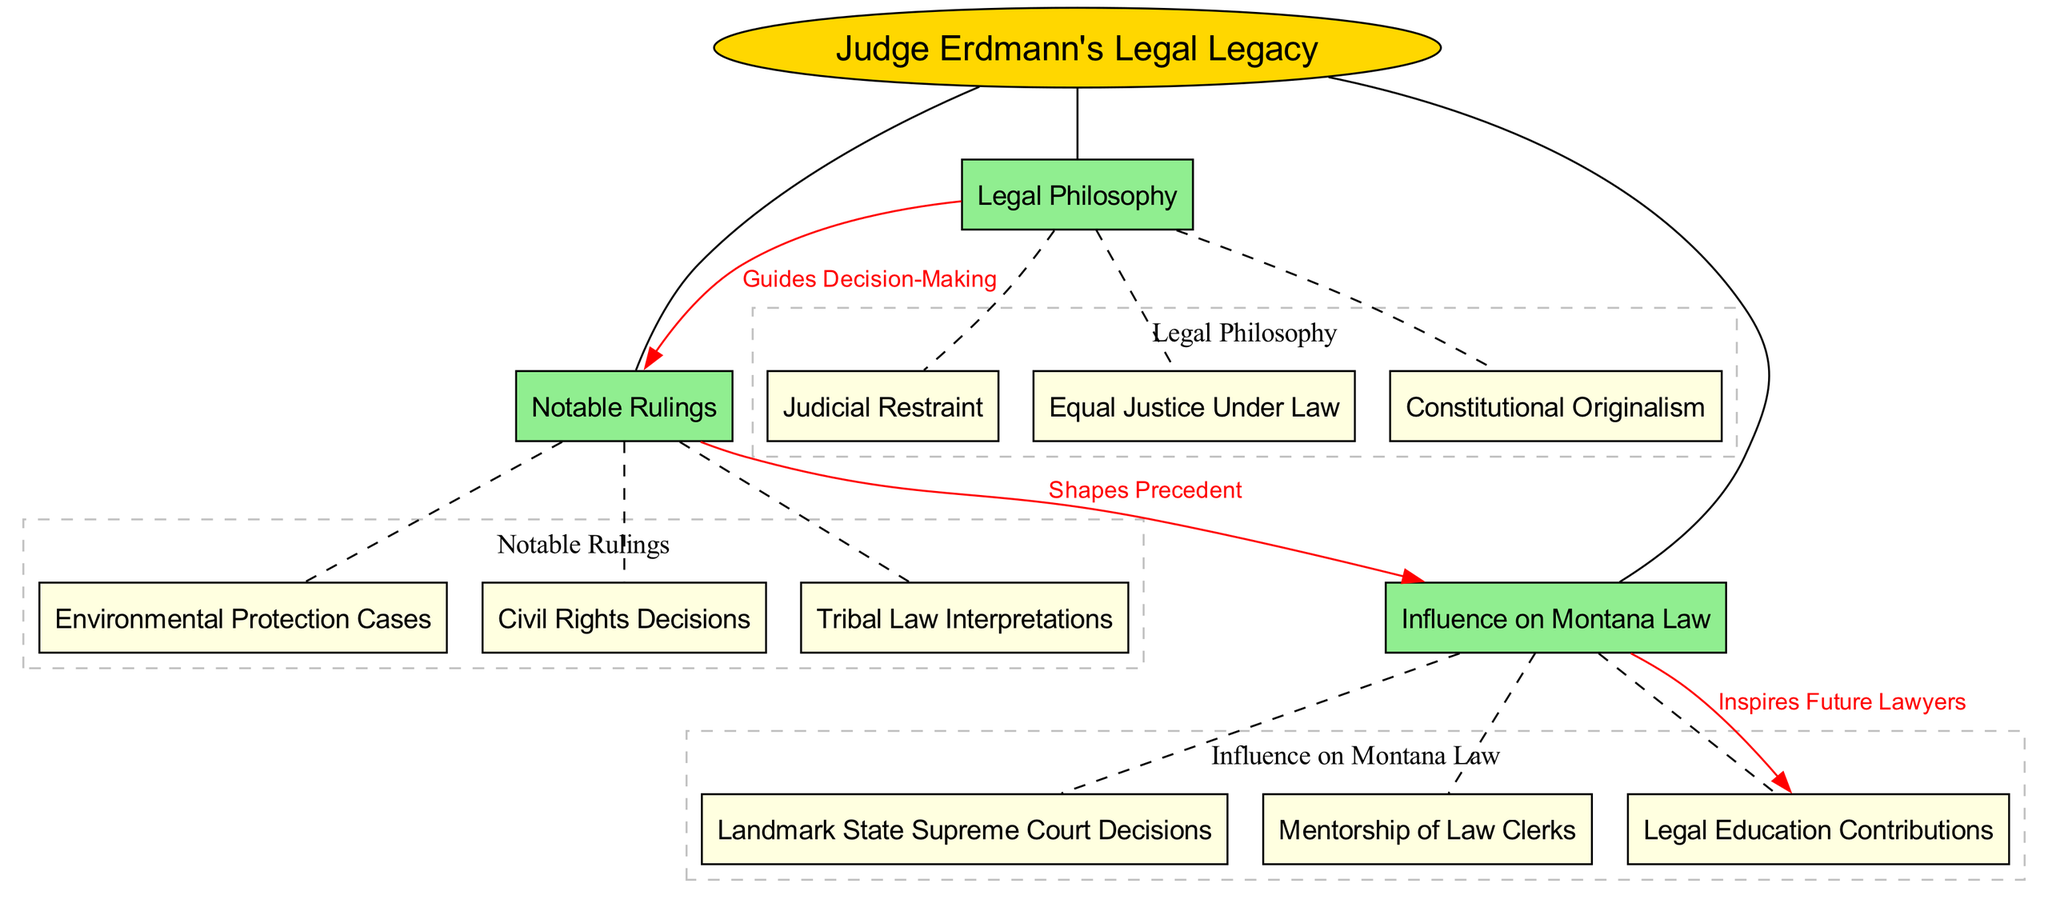What is the central concept of the diagram? The central concept is labeled as "Judge Erdmann's Legal Legacy," which serves as the main topic of the concept map and connects all other nodes.
Answer: Judge Erdmann's Legal Legacy How many main nodes are present in the diagram? The diagram includes three main nodes: "Notable Rulings," "Legal Philosophy," and "Influence on Montana Law." Counting them gives a total of three.
Answer: 3 Which legal philosophy is associated with guiding decision-making? The connection labeled "Guides Decision-Making" links "Legal Philosophy" to "Notable Rulings," indicating that "Constitutional Originalism" is part of the legal philosophies.
Answer: Constitutional Originalism What shapes the precedent in Montana law? The connection labeled "Shapes Precedent" indicates that "Notable Rulings" is influential in shaping the legal precedents, suggesting these rulings are significant for Montana law.
Answer: Notable Rulings What is one of the contributions to legal education mentioned? Under "Influence on Montana Law," the sub-node "Legal Education Contributions" indicates that Judge Erdmann has made contributions to legal education in Montana.
Answer: Legal Education Contributions Which notable ruling relates to environmental issues? The sub-node "Environmental Protection Cases" is located under "Notable Rulings," indicating that it is one of Judge Erdmann's notable rulings relating to environmental issues.
Answer: Environmental Protection Cases How does "Influence on Montana Law" relate to future lawyers? The connection "Inspires Future Lawyers" between "Influence on Montana Law" and "Legal Education Contributions" indicates that Judge Erdmann's influence fosters inspiration among future lawyers.
Answer: Inspires Future Lawyers What is the label for the connection from "Legal Philosophy" to "Notable Rulings"? The connection from "Legal Philosophy" to "Notable Rulings" is labeled "Guides Decision-Making," indicating a directional influence in the reasoning process.
Answer: Guides Decision-Making In what area did Judge Erdmann notably interpret law? The sub-node "Tribal Law Interpretations" indicates that one of the notable areas of ruling by Judge Erdmann involves interpretations related to tribal law.
Answer: Tribal Law Interpretations 